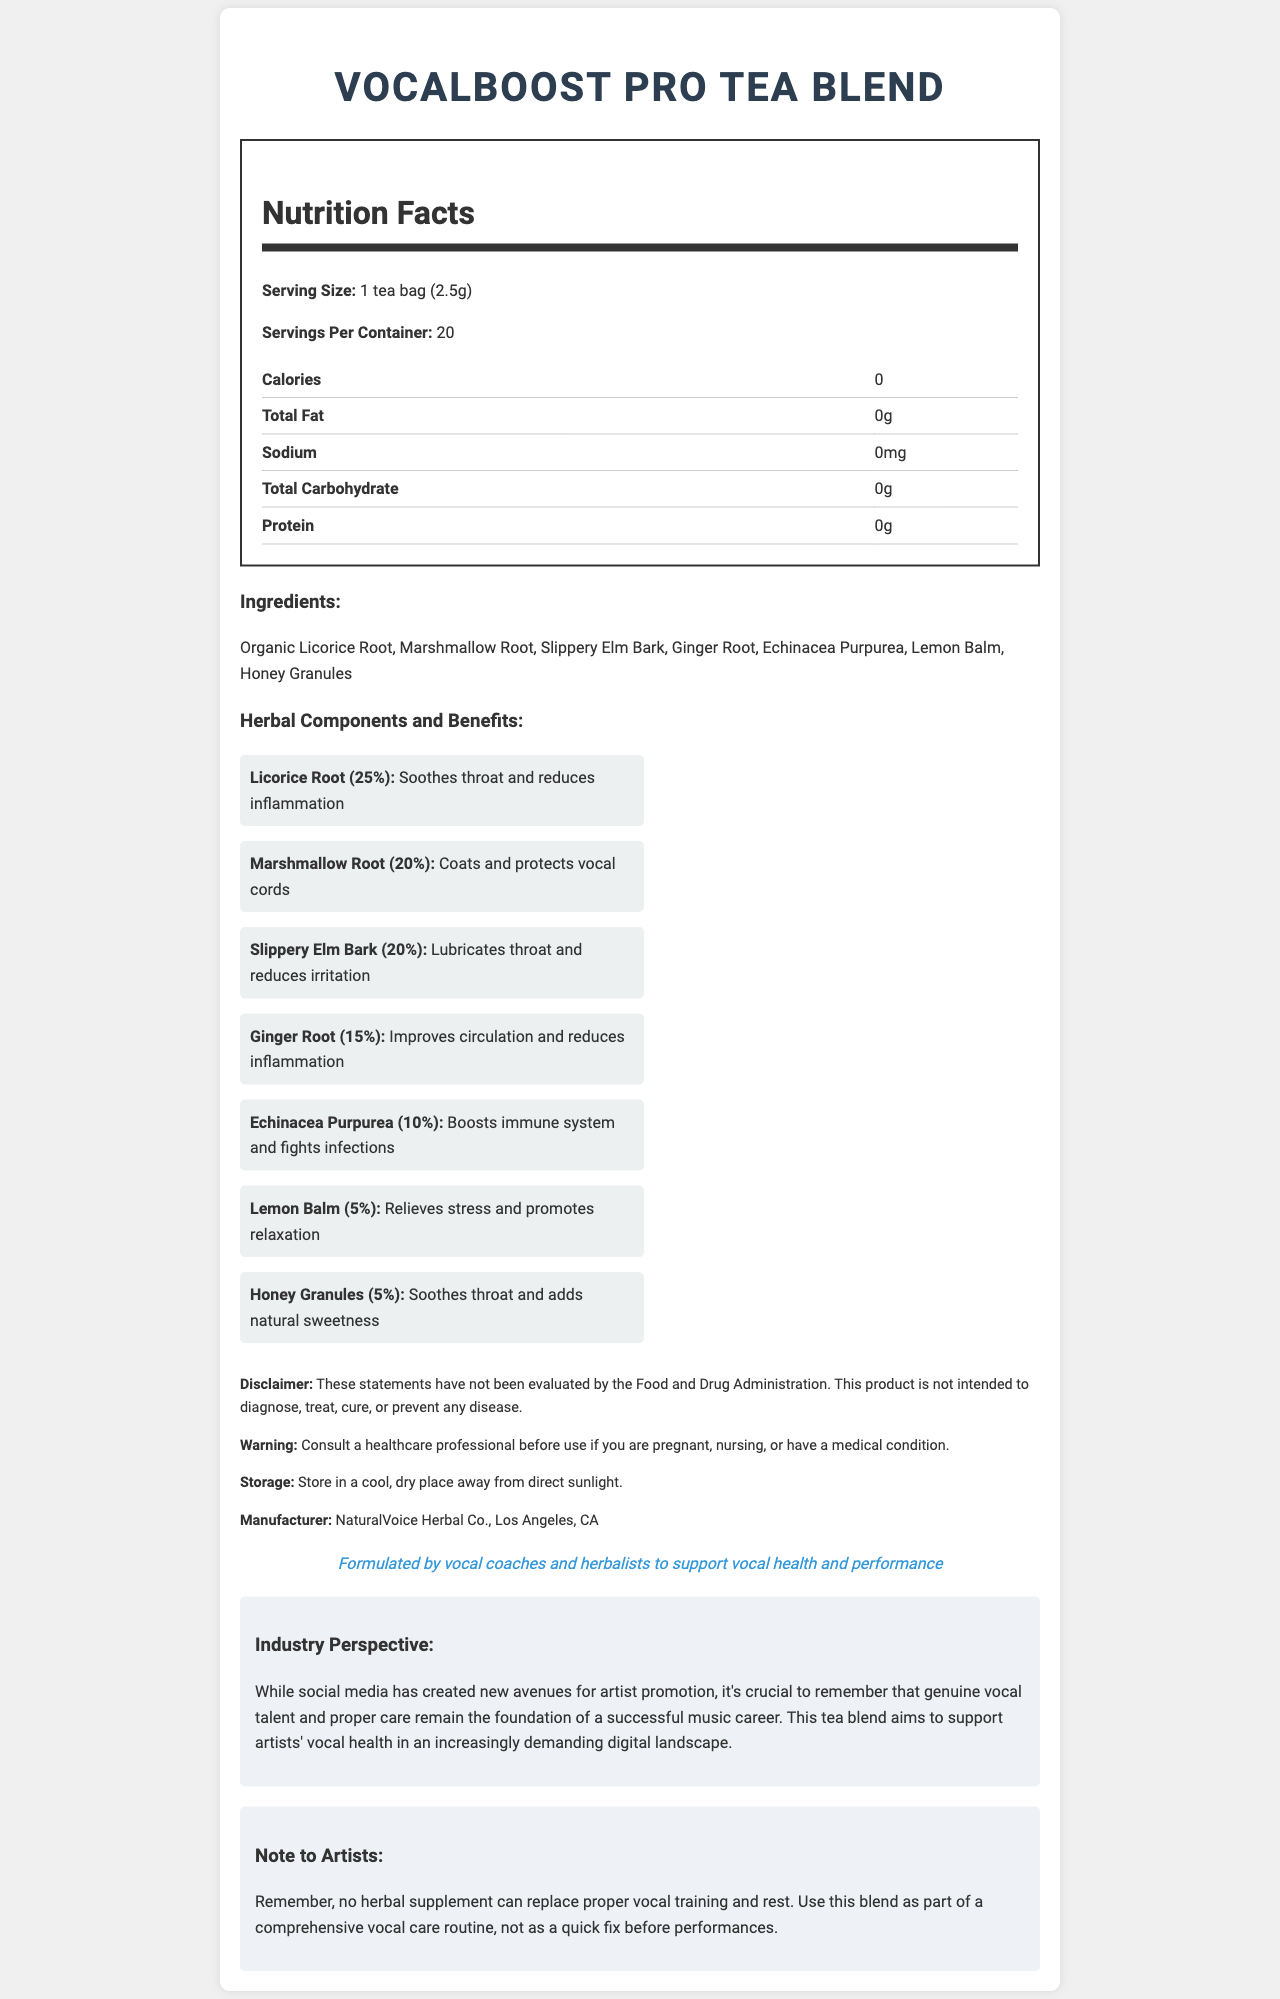what is the serving size of VocalBoost Pro Tea Blend? The serving size information is clearly listed under the Nutrition Facts section of the document.
Answer: 1 tea bag (2.5g) how many servings per container are in VocalBoost Pro Tea Blend? This information is stated directly in the Nutrition Facts section as "Servings Per Container: 20".
Answer: 20 how many calories are in each serving of the tea blend? The calories per serving are listed in the Nutrition Facts table and it shows "Calories: 0."
Answer: 0 what are the main herbal components used in the tea blend? These ingredients are listed under the "Ingredients" section and further detailed with their benefits under "Herbal Components and Benefits."
Answer: Licorice Root, Marshmallow Root, Slippery Elm Bark, Ginger Root, Echinacea Purpurea, Lemon Balm, Honey Granules which ingredient has the highest percentage in the tea blend? Licorice Root is listed with a benefit and a percentage of 25%, the highest among all listed ingredients in the Herbal Components section.
Answer: Licorice Root what benefit does Slippery Elm Bark provide? Slippery Elm Bark’s benefit is clearly mentioned under the “Herbal Components and Benefits” section.
Answer: Lubricates throat and reduces irritation who is the manufacturer of this tea blend? The manufacturer information is listed near the bottom of the document under the "Manufacturer" section.
Answer: NaturalVoice Herbal Co., Los Angeles, CA how should the tea blend be stored? A. In a refrigerator B. In a cool, dry place away from direct sunlight C. At room temperature The correct storage instructions are "Store in a cool, dry place away from direct sunlight," as listed under the "Storage" section.
Answer: B which of the following is NOT an ingredient in the tea blend? i. Licorice Root ii. Marshmallow Root iii. Peppermint iv. Ginger Root Peppermint is not listed among the ingredients; Licorice Root, Marshmallow Root, and Ginger Root are included in the blend.
Answer: iii does the tea blend contain any protein? According to the Nutrition Facts table, the tea blend contains 0g of protein.
Answer: No is there a warning about using this product if you are pregnant or have a medical condition? The warning section advises to "Consult a healthcare professional before use if you are pregnant, nursing, or have a medical condition."
Answer: Yes can the benefits claimed by the tea blend be fully trusted to treat diseases? The disclaimer states "These statements have not been evaluated by the Food and Drug Administration. This product is not intended to diagnose, treat, cure, or prevent any disease."
Answer: No summarize the main idea of this document. This document provides comprehensive information about the VocalBoost Pro Tea Blend, focusing on how it supports vocal health through its various herbal components and emphasizes the importance of maintaining proper vocal care.
Answer: The document details the nutritional information, ingredients, and benefits of VocalBoost Pro Tea Blend, a specialty tea aimed at enhancing vocal performance. It includes information on serving size, herbal components and their benefits, a disclaimer about the health claims, storage instructions, warnings, and manufacturer details. what is the distribution method for the VocalBoost Pro Tea Blend? The document does not provide any information regarding the distribution method of the tea blend.
Answer: Not enough information 